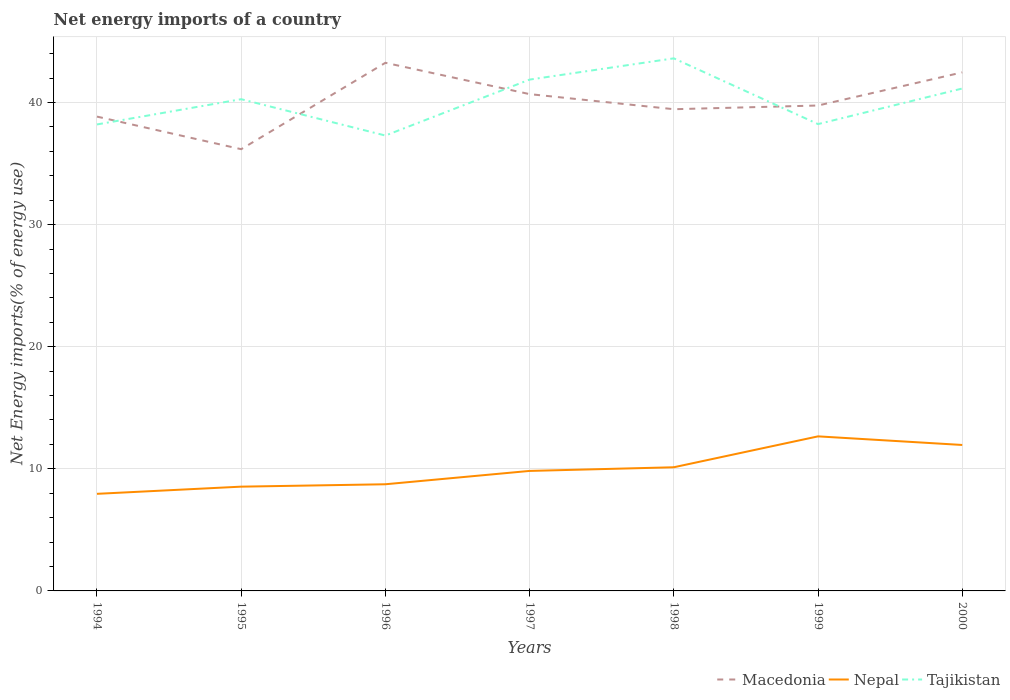How many different coloured lines are there?
Ensure brevity in your answer.  3. Does the line corresponding to Macedonia intersect with the line corresponding to Nepal?
Provide a short and direct response. No. Across all years, what is the maximum net energy imports in Tajikistan?
Your answer should be compact. 37.3. What is the total net energy imports in Nepal in the graph?
Your answer should be compact. -0.3. What is the difference between the highest and the second highest net energy imports in Nepal?
Your answer should be very brief. 4.71. What is the difference between two consecutive major ticks on the Y-axis?
Make the answer very short. 10. Does the graph contain any zero values?
Your answer should be very brief. No. Does the graph contain grids?
Your answer should be very brief. Yes. How are the legend labels stacked?
Give a very brief answer. Horizontal. What is the title of the graph?
Your answer should be very brief. Net energy imports of a country. What is the label or title of the X-axis?
Provide a short and direct response. Years. What is the label or title of the Y-axis?
Make the answer very short. Net Energy imports(% of energy use). What is the Net Energy imports(% of energy use) of Macedonia in 1994?
Provide a succinct answer. 38.85. What is the Net Energy imports(% of energy use) in Nepal in 1994?
Keep it short and to the point. 7.95. What is the Net Energy imports(% of energy use) in Tajikistan in 1994?
Ensure brevity in your answer.  38.21. What is the Net Energy imports(% of energy use) of Macedonia in 1995?
Your answer should be very brief. 36.18. What is the Net Energy imports(% of energy use) of Nepal in 1995?
Keep it short and to the point. 8.54. What is the Net Energy imports(% of energy use) of Tajikistan in 1995?
Make the answer very short. 40.28. What is the Net Energy imports(% of energy use) of Macedonia in 1996?
Ensure brevity in your answer.  43.26. What is the Net Energy imports(% of energy use) of Nepal in 1996?
Offer a terse response. 8.74. What is the Net Energy imports(% of energy use) of Tajikistan in 1996?
Provide a short and direct response. 37.3. What is the Net Energy imports(% of energy use) in Macedonia in 1997?
Offer a terse response. 40.69. What is the Net Energy imports(% of energy use) in Nepal in 1997?
Make the answer very short. 9.83. What is the Net Energy imports(% of energy use) of Tajikistan in 1997?
Ensure brevity in your answer.  41.88. What is the Net Energy imports(% of energy use) in Macedonia in 1998?
Your response must be concise. 39.46. What is the Net Energy imports(% of energy use) in Nepal in 1998?
Your response must be concise. 10.13. What is the Net Energy imports(% of energy use) of Tajikistan in 1998?
Provide a short and direct response. 43.62. What is the Net Energy imports(% of energy use) in Macedonia in 1999?
Keep it short and to the point. 39.76. What is the Net Energy imports(% of energy use) in Nepal in 1999?
Your answer should be compact. 12.66. What is the Net Energy imports(% of energy use) in Tajikistan in 1999?
Give a very brief answer. 38.24. What is the Net Energy imports(% of energy use) in Macedonia in 2000?
Offer a very short reply. 42.47. What is the Net Energy imports(% of energy use) in Nepal in 2000?
Keep it short and to the point. 11.96. What is the Net Energy imports(% of energy use) of Tajikistan in 2000?
Provide a short and direct response. 41.15. Across all years, what is the maximum Net Energy imports(% of energy use) in Macedonia?
Give a very brief answer. 43.26. Across all years, what is the maximum Net Energy imports(% of energy use) in Nepal?
Give a very brief answer. 12.66. Across all years, what is the maximum Net Energy imports(% of energy use) in Tajikistan?
Offer a terse response. 43.62. Across all years, what is the minimum Net Energy imports(% of energy use) in Macedonia?
Give a very brief answer. 36.18. Across all years, what is the minimum Net Energy imports(% of energy use) in Nepal?
Your answer should be compact. 7.95. Across all years, what is the minimum Net Energy imports(% of energy use) in Tajikistan?
Ensure brevity in your answer.  37.3. What is the total Net Energy imports(% of energy use) in Macedonia in the graph?
Your response must be concise. 280.67. What is the total Net Energy imports(% of energy use) of Nepal in the graph?
Your answer should be compact. 69.8. What is the total Net Energy imports(% of energy use) of Tajikistan in the graph?
Your answer should be very brief. 280.68. What is the difference between the Net Energy imports(% of energy use) of Macedonia in 1994 and that in 1995?
Provide a short and direct response. 2.67. What is the difference between the Net Energy imports(% of energy use) of Nepal in 1994 and that in 1995?
Keep it short and to the point. -0.59. What is the difference between the Net Energy imports(% of energy use) in Tajikistan in 1994 and that in 1995?
Give a very brief answer. -2.07. What is the difference between the Net Energy imports(% of energy use) of Macedonia in 1994 and that in 1996?
Provide a succinct answer. -4.41. What is the difference between the Net Energy imports(% of energy use) of Nepal in 1994 and that in 1996?
Your answer should be very brief. -0.78. What is the difference between the Net Energy imports(% of energy use) in Tajikistan in 1994 and that in 1996?
Your answer should be compact. 0.91. What is the difference between the Net Energy imports(% of energy use) in Macedonia in 1994 and that in 1997?
Your response must be concise. -1.84. What is the difference between the Net Energy imports(% of energy use) of Nepal in 1994 and that in 1997?
Provide a succinct answer. -1.88. What is the difference between the Net Energy imports(% of energy use) of Tajikistan in 1994 and that in 1997?
Offer a very short reply. -3.67. What is the difference between the Net Energy imports(% of energy use) in Macedonia in 1994 and that in 1998?
Offer a terse response. -0.6. What is the difference between the Net Energy imports(% of energy use) of Nepal in 1994 and that in 1998?
Your response must be concise. -2.18. What is the difference between the Net Energy imports(% of energy use) of Tajikistan in 1994 and that in 1998?
Your response must be concise. -5.41. What is the difference between the Net Energy imports(% of energy use) of Macedonia in 1994 and that in 1999?
Provide a succinct answer. -0.91. What is the difference between the Net Energy imports(% of energy use) in Nepal in 1994 and that in 1999?
Give a very brief answer. -4.71. What is the difference between the Net Energy imports(% of energy use) of Tajikistan in 1994 and that in 1999?
Ensure brevity in your answer.  -0.03. What is the difference between the Net Energy imports(% of energy use) in Macedonia in 1994 and that in 2000?
Give a very brief answer. -3.62. What is the difference between the Net Energy imports(% of energy use) of Nepal in 1994 and that in 2000?
Your answer should be very brief. -4. What is the difference between the Net Energy imports(% of energy use) in Tajikistan in 1994 and that in 2000?
Give a very brief answer. -2.94. What is the difference between the Net Energy imports(% of energy use) in Macedonia in 1995 and that in 1996?
Ensure brevity in your answer.  -7.08. What is the difference between the Net Energy imports(% of energy use) of Nepal in 1995 and that in 1996?
Make the answer very short. -0.2. What is the difference between the Net Energy imports(% of energy use) of Tajikistan in 1995 and that in 1996?
Ensure brevity in your answer.  2.98. What is the difference between the Net Energy imports(% of energy use) of Macedonia in 1995 and that in 1997?
Your response must be concise. -4.51. What is the difference between the Net Energy imports(% of energy use) in Nepal in 1995 and that in 1997?
Keep it short and to the point. -1.29. What is the difference between the Net Energy imports(% of energy use) in Tajikistan in 1995 and that in 1997?
Keep it short and to the point. -1.61. What is the difference between the Net Energy imports(% of energy use) in Macedonia in 1995 and that in 1998?
Make the answer very short. -3.27. What is the difference between the Net Energy imports(% of energy use) of Nepal in 1995 and that in 1998?
Offer a terse response. -1.59. What is the difference between the Net Energy imports(% of energy use) in Tajikistan in 1995 and that in 1998?
Give a very brief answer. -3.35. What is the difference between the Net Energy imports(% of energy use) of Macedonia in 1995 and that in 1999?
Keep it short and to the point. -3.58. What is the difference between the Net Energy imports(% of energy use) in Nepal in 1995 and that in 1999?
Make the answer very short. -4.12. What is the difference between the Net Energy imports(% of energy use) of Tajikistan in 1995 and that in 1999?
Give a very brief answer. 2.04. What is the difference between the Net Energy imports(% of energy use) in Macedonia in 1995 and that in 2000?
Your answer should be compact. -6.29. What is the difference between the Net Energy imports(% of energy use) of Nepal in 1995 and that in 2000?
Make the answer very short. -3.41. What is the difference between the Net Energy imports(% of energy use) of Tajikistan in 1995 and that in 2000?
Offer a very short reply. -0.88. What is the difference between the Net Energy imports(% of energy use) in Macedonia in 1996 and that in 1997?
Give a very brief answer. 2.57. What is the difference between the Net Energy imports(% of energy use) in Nepal in 1996 and that in 1997?
Provide a succinct answer. -1.09. What is the difference between the Net Energy imports(% of energy use) in Tajikistan in 1996 and that in 1997?
Ensure brevity in your answer.  -4.58. What is the difference between the Net Energy imports(% of energy use) in Macedonia in 1996 and that in 1998?
Your response must be concise. 3.8. What is the difference between the Net Energy imports(% of energy use) of Nepal in 1996 and that in 1998?
Your answer should be very brief. -1.39. What is the difference between the Net Energy imports(% of energy use) of Tajikistan in 1996 and that in 1998?
Provide a succinct answer. -6.32. What is the difference between the Net Energy imports(% of energy use) of Macedonia in 1996 and that in 1999?
Provide a short and direct response. 3.5. What is the difference between the Net Energy imports(% of energy use) of Nepal in 1996 and that in 1999?
Provide a short and direct response. -3.92. What is the difference between the Net Energy imports(% of energy use) of Tajikistan in 1996 and that in 1999?
Keep it short and to the point. -0.94. What is the difference between the Net Energy imports(% of energy use) of Macedonia in 1996 and that in 2000?
Ensure brevity in your answer.  0.79. What is the difference between the Net Energy imports(% of energy use) in Nepal in 1996 and that in 2000?
Your answer should be very brief. -3.22. What is the difference between the Net Energy imports(% of energy use) in Tajikistan in 1996 and that in 2000?
Make the answer very short. -3.85. What is the difference between the Net Energy imports(% of energy use) of Macedonia in 1997 and that in 1998?
Offer a terse response. 1.24. What is the difference between the Net Energy imports(% of energy use) in Nepal in 1997 and that in 1998?
Give a very brief answer. -0.3. What is the difference between the Net Energy imports(% of energy use) in Tajikistan in 1997 and that in 1998?
Make the answer very short. -1.74. What is the difference between the Net Energy imports(% of energy use) in Macedonia in 1997 and that in 1999?
Keep it short and to the point. 0.93. What is the difference between the Net Energy imports(% of energy use) in Nepal in 1997 and that in 1999?
Make the answer very short. -2.83. What is the difference between the Net Energy imports(% of energy use) of Tajikistan in 1997 and that in 1999?
Ensure brevity in your answer.  3.64. What is the difference between the Net Energy imports(% of energy use) in Macedonia in 1997 and that in 2000?
Offer a terse response. -1.78. What is the difference between the Net Energy imports(% of energy use) in Nepal in 1997 and that in 2000?
Make the answer very short. -2.13. What is the difference between the Net Energy imports(% of energy use) of Tajikistan in 1997 and that in 2000?
Give a very brief answer. 0.73. What is the difference between the Net Energy imports(% of energy use) of Macedonia in 1998 and that in 1999?
Offer a terse response. -0.3. What is the difference between the Net Energy imports(% of energy use) in Nepal in 1998 and that in 1999?
Offer a very short reply. -2.53. What is the difference between the Net Energy imports(% of energy use) of Tajikistan in 1998 and that in 1999?
Give a very brief answer. 5.38. What is the difference between the Net Energy imports(% of energy use) in Macedonia in 1998 and that in 2000?
Your response must be concise. -3.02. What is the difference between the Net Energy imports(% of energy use) of Nepal in 1998 and that in 2000?
Your answer should be compact. -1.83. What is the difference between the Net Energy imports(% of energy use) of Tajikistan in 1998 and that in 2000?
Your response must be concise. 2.47. What is the difference between the Net Energy imports(% of energy use) of Macedonia in 1999 and that in 2000?
Provide a succinct answer. -2.71. What is the difference between the Net Energy imports(% of energy use) of Nepal in 1999 and that in 2000?
Offer a terse response. 0.7. What is the difference between the Net Energy imports(% of energy use) in Tajikistan in 1999 and that in 2000?
Your response must be concise. -2.91. What is the difference between the Net Energy imports(% of energy use) in Macedonia in 1994 and the Net Energy imports(% of energy use) in Nepal in 1995?
Your answer should be very brief. 30.31. What is the difference between the Net Energy imports(% of energy use) in Macedonia in 1994 and the Net Energy imports(% of energy use) in Tajikistan in 1995?
Ensure brevity in your answer.  -1.42. What is the difference between the Net Energy imports(% of energy use) in Nepal in 1994 and the Net Energy imports(% of energy use) in Tajikistan in 1995?
Ensure brevity in your answer.  -32.32. What is the difference between the Net Energy imports(% of energy use) of Macedonia in 1994 and the Net Energy imports(% of energy use) of Nepal in 1996?
Ensure brevity in your answer.  30.11. What is the difference between the Net Energy imports(% of energy use) of Macedonia in 1994 and the Net Energy imports(% of energy use) of Tajikistan in 1996?
Provide a succinct answer. 1.55. What is the difference between the Net Energy imports(% of energy use) in Nepal in 1994 and the Net Energy imports(% of energy use) in Tajikistan in 1996?
Keep it short and to the point. -29.35. What is the difference between the Net Energy imports(% of energy use) of Macedonia in 1994 and the Net Energy imports(% of energy use) of Nepal in 1997?
Keep it short and to the point. 29.02. What is the difference between the Net Energy imports(% of energy use) of Macedonia in 1994 and the Net Energy imports(% of energy use) of Tajikistan in 1997?
Offer a very short reply. -3.03. What is the difference between the Net Energy imports(% of energy use) of Nepal in 1994 and the Net Energy imports(% of energy use) of Tajikistan in 1997?
Offer a terse response. -33.93. What is the difference between the Net Energy imports(% of energy use) of Macedonia in 1994 and the Net Energy imports(% of energy use) of Nepal in 1998?
Make the answer very short. 28.72. What is the difference between the Net Energy imports(% of energy use) in Macedonia in 1994 and the Net Energy imports(% of energy use) in Tajikistan in 1998?
Offer a terse response. -4.77. What is the difference between the Net Energy imports(% of energy use) of Nepal in 1994 and the Net Energy imports(% of energy use) of Tajikistan in 1998?
Offer a very short reply. -35.67. What is the difference between the Net Energy imports(% of energy use) of Macedonia in 1994 and the Net Energy imports(% of energy use) of Nepal in 1999?
Make the answer very short. 26.19. What is the difference between the Net Energy imports(% of energy use) in Macedonia in 1994 and the Net Energy imports(% of energy use) in Tajikistan in 1999?
Give a very brief answer. 0.61. What is the difference between the Net Energy imports(% of energy use) in Nepal in 1994 and the Net Energy imports(% of energy use) in Tajikistan in 1999?
Keep it short and to the point. -30.28. What is the difference between the Net Energy imports(% of energy use) of Macedonia in 1994 and the Net Energy imports(% of energy use) of Nepal in 2000?
Keep it short and to the point. 26.9. What is the difference between the Net Energy imports(% of energy use) of Macedonia in 1994 and the Net Energy imports(% of energy use) of Tajikistan in 2000?
Keep it short and to the point. -2.3. What is the difference between the Net Energy imports(% of energy use) of Nepal in 1994 and the Net Energy imports(% of energy use) of Tajikistan in 2000?
Provide a short and direct response. -33.2. What is the difference between the Net Energy imports(% of energy use) in Macedonia in 1995 and the Net Energy imports(% of energy use) in Nepal in 1996?
Your response must be concise. 27.45. What is the difference between the Net Energy imports(% of energy use) of Macedonia in 1995 and the Net Energy imports(% of energy use) of Tajikistan in 1996?
Keep it short and to the point. -1.12. What is the difference between the Net Energy imports(% of energy use) of Nepal in 1995 and the Net Energy imports(% of energy use) of Tajikistan in 1996?
Your response must be concise. -28.76. What is the difference between the Net Energy imports(% of energy use) in Macedonia in 1995 and the Net Energy imports(% of energy use) in Nepal in 1997?
Provide a short and direct response. 26.35. What is the difference between the Net Energy imports(% of energy use) of Macedonia in 1995 and the Net Energy imports(% of energy use) of Tajikistan in 1997?
Make the answer very short. -5.7. What is the difference between the Net Energy imports(% of energy use) in Nepal in 1995 and the Net Energy imports(% of energy use) in Tajikistan in 1997?
Offer a terse response. -33.34. What is the difference between the Net Energy imports(% of energy use) in Macedonia in 1995 and the Net Energy imports(% of energy use) in Nepal in 1998?
Make the answer very short. 26.05. What is the difference between the Net Energy imports(% of energy use) of Macedonia in 1995 and the Net Energy imports(% of energy use) of Tajikistan in 1998?
Give a very brief answer. -7.44. What is the difference between the Net Energy imports(% of energy use) in Nepal in 1995 and the Net Energy imports(% of energy use) in Tajikistan in 1998?
Provide a succinct answer. -35.08. What is the difference between the Net Energy imports(% of energy use) in Macedonia in 1995 and the Net Energy imports(% of energy use) in Nepal in 1999?
Your response must be concise. 23.52. What is the difference between the Net Energy imports(% of energy use) of Macedonia in 1995 and the Net Energy imports(% of energy use) of Tajikistan in 1999?
Offer a very short reply. -2.06. What is the difference between the Net Energy imports(% of energy use) of Nepal in 1995 and the Net Energy imports(% of energy use) of Tajikistan in 1999?
Your answer should be compact. -29.7. What is the difference between the Net Energy imports(% of energy use) of Macedonia in 1995 and the Net Energy imports(% of energy use) of Nepal in 2000?
Your response must be concise. 24.23. What is the difference between the Net Energy imports(% of energy use) of Macedonia in 1995 and the Net Energy imports(% of energy use) of Tajikistan in 2000?
Offer a terse response. -4.97. What is the difference between the Net Energy imports(% of energy use) of Nepal in 1995 and the Net Energy imports(% of energy use) of Tajikistan in 2000?
Your response must be concise. -32.61. What is the difference between the Net Energy imports(% of energy use) in Macedonia in 1996 and the Net Energy imports(% of energy use) in Nepal in 1997?
Offer a terse response. 33.43. What is the difference between the Net Energy imports(% of energy use) in Macedonia in 1996 and the Net Energy imports(% of energy use) in Tajikistan in 1997?
Provide a short and direct response. 1.38. What is the difference between the Net Energy imports(% of energy use) of Nepal in 1996 and the Net Energy imports(% of energy use) of Tajikistan in 1997?
Give a very brief answer. -33.15. What is the difference between the Net Energy imports(% of energy use) in Macedonia in 1996 and the Net Energy imports(% of energy use) in Nepal in 1998?
Your response must be concise. 33.13. What is the difference between the Net Energy imports(% of energy use) of Macedonia in 1996 and the Net Energy imports(% of energy use) of Tajikistan in 1998?
Your answer should be compact. -0.36. What is the difference between the Net Energy imports(% of energy use) in Nepal in 1996 and the Net Energy imports(% of energy use) in Tajikistan in 1998?
Offer a very short reply. -34.89. What is the difference between the Net Energy imports(% of energy use) in Macedonia in 1996 and the Net Energy imports(% of energy use) in Nepal in 1999?
Your answer should be very brief. 30.6. What is the difference between the Net Energy imports(% of energy use) of Macedonia in 1996 and the Net Energy imports(% of energy use) of Tajikistan in 1999?
Offer a terse response. 5.02. What is the difference between the Net Energy imports(% of energy use) in Nepal in 1996 and the Net Energy imports(% of energy use) in Tajikistan in 1999?
Your answer should be very brief. -29.5. What is the difference between the Net Energy imports(% of energy use) of Macedonia in 1996 and the Net Energy imports(% of energy use) of Nepal in 2000?
Keep it short and to the point. 31.3. What is the difference between the Net Energy imports(% of energy use) of Macedonia in 1996 and the Net Energy imports(% of energy use) of Tajikistan in 2000?
Your answer should be compact. 2.11. What is the difference between the Net Energy imports(% of energy use) of Nepal in 1996 and the Net Energy imports(% of energy use) of Tajikistan in 2000?
Provide a succinct answer. -32.41. What is the difference between the Net Energy imports(% of energy use) in Macedonia in 1997 and the Net Energy imports(% of energy use) in Nepal in 1998?
Provide a short and direct response. 30.56. What is the difference between the Net Energy imports(% of energy use) in Macedonia in 1997 and the Net Energy imports(% of energy use) in Tajikistan in 1998?
Make the answer very short. -2.93. What is the difference between the Net Energy imports(% of energy use) in Nepal in 1997 and the Net Energy imports(% of energy use) in Tajikistan in 1998?
Your answer should be very brief. -33.79. What is the difference between the Net Energy imports(% of energy use) of Macedonia in 1997 and the Net Energy imports(% of energy use) of Nepal in 1999?
Give a very brief answer. 28.03. What is the difference between the Net Energy imports(% of energy use) in Macedonia in 1997 and the Net Energy imports(% of energy use) in Tajikistan in 1999?
Your answer should be very brief. 2.45. What is the difference between the Net Energy imports(% of energy use) of Nepal in 1997 and the Net Energy imports(% of energy use) of Tajikistan in 1999?
Make the answer very short. -28.41. What is the difference between the Net Energy imports(% of energy use) in Macedonia in 1997 and the Net Energy imports(% of energy use) in Nepal in 2000?
Offer a very short reply. 28.74. What is the difference between the Net Energy imports(% of energy use) in Macedonia in 1997 and the Net Energy imports(% of energy use) in Tajikistan in 2000?
Keep it short and to the point. -0.46. What is the difference between the Net Energy imports(% of energy use) of Nepal in 1997 and the Net Energy imports(% of energy use) of Tajikistan in 2000?
Provide a succinct answer. -31.32. What is the difference between the Net Energy imports(% of energy use) of Macedonia in 1998 and the Net Energy imports(% of energy use) of Nepal in 1999?
Provide a succinct answer. 26.8. What is the difference between the Net Energy imports(% of energy use) of Macedonia in 1998 and the Net Energy imports(% of energy use) of Tajikistan in 1999?
Give a very brief answer. 1.22. What is the difference between the Net Energy imports(% of energy use) in Nepal in 1998 and the Net Energy imports(% of energy use) in Tajikistan in 1999?
Offer a very short reply. -28.11. What is the difference between the Net Energy imports(% of energy use) of Macedonia in 1998 and the Net Energy imports(% of energy use) of Nepal in 2000?
Offer a terse response. 27.5. What is the difference between the Net Energy imports(% of energy use) of Macedonia in 1998 and the Net Energy imports(% of energy use) of Tajikistan in 2000?
Keep it short and to the point. -1.7. What is the difference between the Net Energy imports(% of energy use) of Nepal in 1998 and the Net Energy imports(% of energy use) of Tajikistan in 2000?
Make the answer very short. -31.02. What is the difference between the Net Energy imports(% of energy use) of Macedonia in 1999 and the Net Energy imports(% of energy use) of Nepal in 2000?
Offer a terse response. 27.8. What is the difference between the Net Energy imports(% of energy use) in Macedonia in 1999 and the Net Energy imports(% of energy use) in Tajikistan in 2000?
Your answer should be compact. -1.39. What is the difference between the Net Energy imports(% of energy use) in Nepal in 1999 and the Net Energy imports(% of energy use) in Tajikistan in 2000?
Ensure brevity in your answer.  -28.49. What is the average Net Energy imports(% of energy use) of Macedonia per year?
Give a very brief answer. 40.1. What is the average Net Energy imports(% of energy use) in Nepal per year?
Make the answer very short. 9.97. What is the average Net Energy imports(% of energy use) of Tajikistan per year?
Provide a succinct answer. 40.1. In the year 1994, what is the difference between the Net Energy imports(% of energy use) of Macedonia and Net Energy imports(% of energy use) of Nepal?
Make the answer very short. 30.9. In the year 1994, what is the difference between the Net Energy imports(% of energy use) of Macedonia and Net Energy imports(% of energy use) of Tajikistan?
Make the answer very short. 0.64. In the year 1994, what is the difference between the Net Energy imports(% of energy use) of Nepal and Net Energy imports(% of energy use) of Tajikistan?
Your answer should be very brief. -30.26. In the year 1995, what is the difference between the Net Energy imports(% of energy use) of Macedonia and Net Energy imports(% of energy use) of Nepal?
Provide a succinct answer. 27.64. In the year 1995, what is the difference between the Net Energy imports(% of energy use) of Macedonia and Net Energy imports(% of energy use) of Tajikistan?
Your answer should be compact. -4.09. In the year 1995, what is the difference between the Net Energy imports(% of energy use) in Nepal and Net Energy imports(% of energy use) in Tajikistan?
Offer a terse response. -31.73. In the year 1996, what is the difference between the Net Energy imports(% of energy use) in Macedonia and Net Energy imports(% of energy use) in Nepal?
Ensure brevity in your answer.  34.52. In the year 1996, what is the difference between the Net Energy imports(% of energy use) of Macedonia and Net Energy imports(% of energy use) of Tajikistan?
Make the answer very short. 5.96. In the year 1996, what is the difference between the Net Energy imports(% of energy use) of Nepal and Net Energy imports(% of energy use) of Tajikistan?
Offer a very short reply. -28.56. In the year 1997, what is the difference between the Net Energy imports(% of energy use) in Macedonia and Net Energy imports(% of energy use) in Nepal?
Make the answer very short. 30.86. In the year 1997, what is the difference between the Net Energy imports(% of energy use) in Macedonia and Net Energy imports(% of energy use) in Tajikistan?
Provide a succinct answer. -1.19. In the year 1997, what is the difference between the Net Energy imports(% of energy use) of Nepal and Net Energy imports(% of energy use) of Tajikistan?
Give a very brief answer. -32.05. In the year 1998, what is the difference between the Net Energy imports(% of energy use) in Macedonia and Net Energy imports(% of energy use) in Nepal?
Your answer should be very brief. 29.33. In the year 1998, what is the difference between the Net Energy imports(% of energy use) in Macedonia and Net Energy imports(% of energy use) in Tajikistan?
Give a very brief answer. -4.17. In the year 1998, what is the difference between the Net Energy imports(% of energy use) of Nepal and Net Energy imports(% of energy use) of Tajikistan?
Your response must be concise. -33.49. In the year 1999, what is the difference between the Net Energy imports(% of energy use) in Macedonia and Net Energy imports(% of energy use) in Nepal?
Keep it short and to the point. 27.1. In the year 1999, what is the difference between the Net Energy imports(% of energy use) of Macedonia and Net Energy imports(% of energy use) of Tajikistan?
Keep it short and to the point. 1.52. In the year 1999, what is the difference between the Net Energy imports(% of energy use) of Nepal and Net Energy imports(% of energy use) of Tajikistan?
Your response must be concise. -25.58. In the year 2000, what is the difference between the Net Energy imports(% of energy use) of Macedonia and Net Energy imports(% of energy use) of Nepal?
Provide a succinct answer. 30.52. In the year 2000, what is the difference between the Net Energy imports(% of energy use) in Macedonia and Net Energy imports(% of energy use) in Tajikistan?
Offer a terse response. 1.32. In the year 2000, what is the difference between the Net Energy imports(% of energy use) of Nepal and Net Energy imports(% of energy use) of Tajikistan?
Ensure brevity in your answer.  -29.2. What is the ratio of the Net Energy imports(% of energy use) in Macedonia in 1994 to that in 1995?
Your answer should be compact. 1.07. What is the ratio of the Net Energy imports(% of energy use) of Nepal in 1994 to that in 1995?
Keep it short and to the point. 0.93. What is the ratio of the Net Energy imports(% of energy use) in Tajikistan in 1994 to that in 1995?
Make the answer very short. 0.95. What is the ratio of the Net Energy imports(% of energy use) in Macedonia in 1994 to that in 1996?
Offer a very short reply. 0.9. What is the ratio of the Net Energy imports(% of energy use) of Nepal in 1994 to that in 1996?
Offer a very short reply. 0.91. What is the ratio of the Net Energy imports(% of energy use) in Tajikistan in 1994 to that in 1996?
Make the answer very short. 1.02. What is the ratio of the Net Energy imports(% of energy use) in Macedonia in 1994 to that in 1997?
Provide a succinct answer. 0.95. What is the ratio of the Net Energy imports(% of energy use) of Nepal in 1994 to that in 1997?
Keep it short and to the point. 0.81. What is the ratio of the Net Energy imports(% of energy use) of Tajikistan in 1994 to that in 1997?
Provide a short and direct response. 0.91. What is the ratio of the Net Energy imports(% of energy use) of Macedonia in 1994 to that in 1998?
Your answer should be very brief. 0.98. What is the ratio of the Net Energy imports(% of energy use) of Nepal in 1994 to that in 1998?
Your answer should be very brief. 0.79. What is the ratio of the Net Energy imports(% of energy use) of Tajikistan in 1994 to that in 1998?
Your response must be concise. 0.88. What is the ratio of the Net Energy imports(% of energy use) in Macedonia in 1994 to that in 1999?
Your answer should be very brief. 0.98. What is the ratio of the Net Energy imports(% of energy use) of Nepal in 1994 to that in 1999?
Keep it short and to the point. 0.63. What is the ratio of the Net Energy imports(% of energy use) in Tajikistan in 1994 to that in 1999?
Provide a short and direct response. 1. What is the ratio of the Net Energy imports(% of energy use) of Macedonia in 1994 to that in 2000?
Give a very brief answer. 0.91. What is the ratio of the Net Energy imports(% of energy use) of Nepal in 1994 to that in 2000?
Provide a short and direct response. 0.67. What is the ratio of the Net Energy imports(% of energy use) of Tajikistan in 1994 to that in 2000?
Your answer should be very brief. 0.93. What is the ratio of the Net Energy imports(% of energy use) in Macedonia in 1995 to that in 1996?
Make the answer very short. 0.84. What is the ratio of the Net Energy imports(% of energy use) in Nepal in 1995 to that in 1996?
Offer a very short reply. 0.98. What is the ratio of the Net Energy imports(% of energy use) of Tajikistan in 1995 to that in 1996?
Give a very brief answer. 1.08. What is the ratio of the Net Energy imports(% of energy use) in Macedonia in 1995 to that in 1997?
Your response must be concise. 0.89. What is the ratio of the Net Energy imports(% of energy use) of Nepal in 1995 to that in 1997?
Provide a short and direct response. 0.87. What is the ratio of the Net Energy imports(% of energy use) of Tajikistan in 1995 to that in 1997?
Ensure brevity in your answer.  0.96. What is the ratio of the Net Energy imports(% of energy use) of Macedonia in 1995 to that in 1998?
Offer a terse response. 0.92. What is the ratio of the Net Energy imports(% of energy use) of Nepal in 1995 to that in 1998?
Keep it short and to the point. 0.84. What is the ratio of the Net Energy imports(% of energy use) in Tajikistan in 1995 to that in 1998?
Offer a very short reply. 0.92. What is the ratio of the Net Energy imports(% of energy use) of Macedonia in 1995 to that in 1999?
Your answer should be very brief. 0.91. What is the ratio of the Net Energy imports(% of energy use) in Nepal in 1995 to that in 1999?
Your answer should be very brief. 0.67. What is the ratio of the Net Energy imports(% of energy use) in Tajikistan in 1995 to that in 1999?
Your answer should be very brief. 1.05. What is the ratio of the Net Energy imports(% of energy use) of Macedonia in 1995 to that in 2000?
Offer a terse response. 0.85. What is the ratio of the Net Energy imports(% of energy use) in Nepal in 1995 to that in 2000?
Your answer should be compact. 0.71. What is the ratio of the Net Energy imports(% of energy use) of Tajikistan in 1995 to that in 2000?
Ensure brevity in your answer.  0.98. What is the ratio of the Net Energy imports(% of energy use) of Macedonia in 1996 to that in 1997?
Make the answer very short. 1.06. What is the ratio of the Net Energy imports(% of energy use) of Nepal in 1996 to that in 1997?
Your answer should be compact. 0.89. What is the ratio of the Net Energy imports(% of energy use) of Tajikistan in 1996 to that in 1997?
Give a very brief answer. 0.89. What is the ratio of the Net Energy imports(% of energy use) of Macedonia in 1996 to that in 1998?
Ensure brevity in your answer.  1.1. What is the ratio of the Net Energy imports(% of energy use) of Nepal in 1996 to that in 1998?
Make the answer very short. 0.86. What is the ratio of the Net Energy imports(% of energy use) in Tajikistan in 1996 to that in 1998?
Make the answer very short. 0.86. What is the ratio of the Net Energy imports(% of energy use) of Macedonia in 1996 to that in 1999?
Your response must be concise. 1.09. What is the ratio of the Net Energy imports(% of energy use) in Nepal in 1996 to that in 1999?
Offer a very short reply. 0.69. What is the ratio of the Net Energy imports(% of energy use) in Tajikistan in 1996 to that in 1999?
Keep it short and to the point. 0.98. What is the ratio of the Net Energy imports(% of energy use) in Macedonia in 1996 to that in 2000?
Provide a short and direct response. 1.02. What is the ratio of the Net Energy imports(% of energy use) in Nepal in 1996 to that in 2000?
Your response must be concise. 0.73. What is the ratio of the Net Energy imports(% of energy use) of Tajikistan in 1996 to that in 2000?
Make the answer very short. 0.91. What is the ratio of the Net Energy imports(% of energy use) in Macedonia in 1997 to that in 1998?
Your answer should be very brief. 1.03. What is the ratio of the Net Energy imports(% of energy use) in Nepal in 1997 to that in 1998?
Offer a very short reply. 0.97. What is the ratio of the Net Energy imports(% of energy use) of Tajikistan in 1997 to that in 1998?
Make the answer very short. 0.96. What is the ratio of the Net Energy imports(% of energy use) of Macedonia in 1997 to that in 1999?
Your response must be concise. 1.02. What is the ratio of the Net Energy imports(% of energy use) in Nepal in 1997 to that in 1999?
Your answer should be compact. 0.78. What is the ratio of the Net Energy imports(% of energy use) in Tajikistan in 1997 to that in 1999?
Provide a short and direct response. 1.1. What is the ratio of the Net Energy imports(% of energy use) of Macedonia in 1997 to that in 2000?
Give a very brief answer. 0.96. What is the ratio of the Net Energy imports(% of energy use) of Nepal in 1997 to that in 2000?
Your response must be concise. 0.82. What is the ratio of the Net Energy imports(% of energy use) in Tajikistan in 1997 to that in 2000?
Provide a short and direct response. 1.02. What is the ratio of the Net Energy imports(% of energy use) of Macedonia in 1998 to that in 1999?
Your answer should be compact. 0.99. What is the ratio of the Net Energy imports(% of energy use) of Nepal in 1998 to that in 1999?
Offer a very short reply. 0.8. What is the ratio of the Net Energy imports(% of energy use) in Tajikistan in 1998 to that in 1999?
Keep it short and to the point. 1.14. What is the ratio of the Net Energy imports(% of energy use) of Macedonia in 1998 to that in 2000?
Offer a terse response. 0.93. What is the ratio of the Net Energy imports(% of energy use) of Nepal in 1998 to that in 2000?
Make the answer very short. 0.85. What is the ratio of the Net Energy imports(% of energy use) of Tajikistan in 1998 to that in 2000?
Offer a terse response. 1.06. What is the ratio of the Net Energy imports(% of energy use) in Macedonia in 1999 to that in 2000?
Make the answer very short. 0.94. What is the ratio of the Net Energy imports(% of energy use) in Nepal in 1999 to that in 2000?
Make the answer very short. 1.06. What is the ratio of the Net Energy imports(% of energy use) in Tajikistan in 1999 to that in 2000?
Make the answer very short. 0.93. What is the difference between the highest and the second highest Net Energy imports(% of energy use) of Macedonia?
Your answer should be very brief. 0.79. What is the difference between the highest and the second highest Net Energy imports(% of energy use) in Nepal?
Offer a very short reply. 0.7. What is the difference between the highest and the second highest Net Energy imports(% of energy use) in Tajikistan?
Your answer should be very brief. 1.74. What is the difference between the highest and the lowest Net Energy imports(% of energy use) of Macedonia?
Offer a terse response. 7.08. What is the difference between the highest and the lowest Net Energy imports(% of energy use) in Nepal?
Make the answer very short. 4.71. What is the difference between the highest and the lowest Net Energy imports(% of energy use) in Tajikistan?
Make the answer very short. 6.32. 